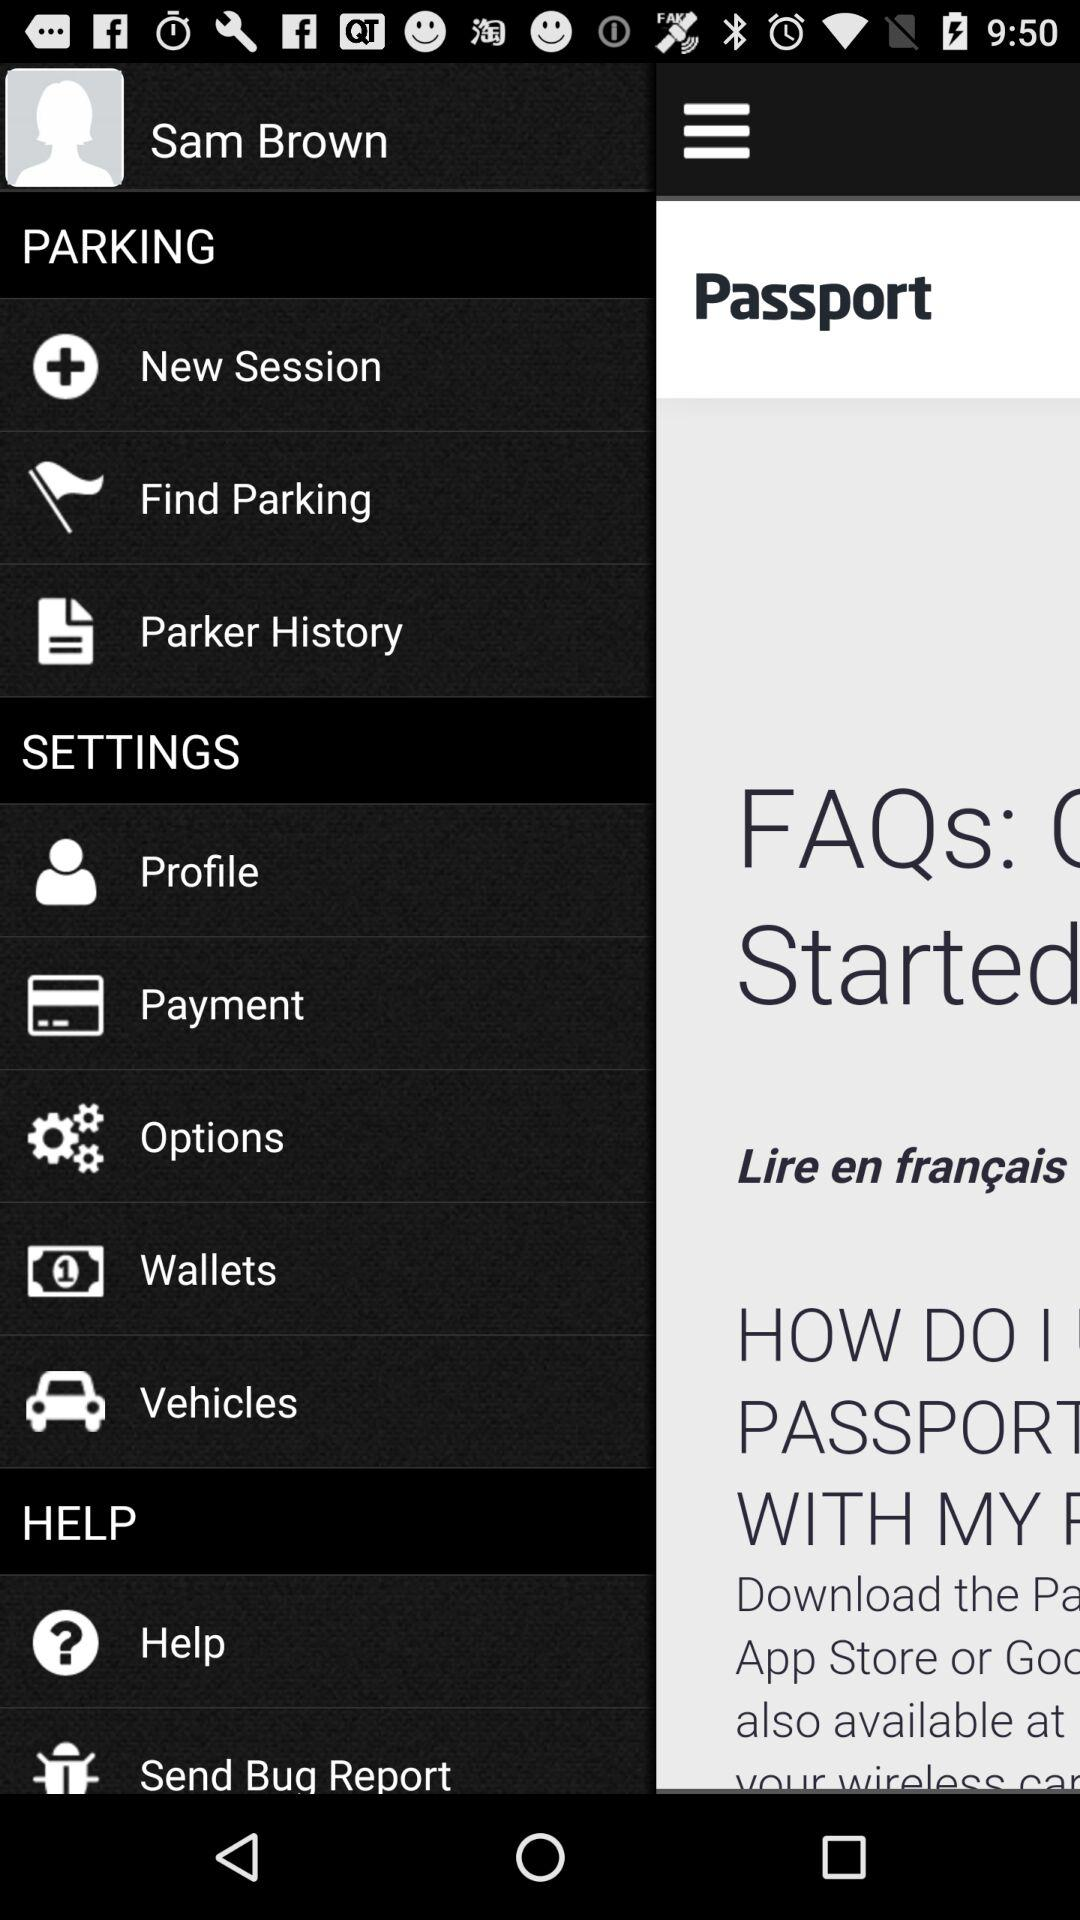What is the user name? The user name is Sam Brown. 